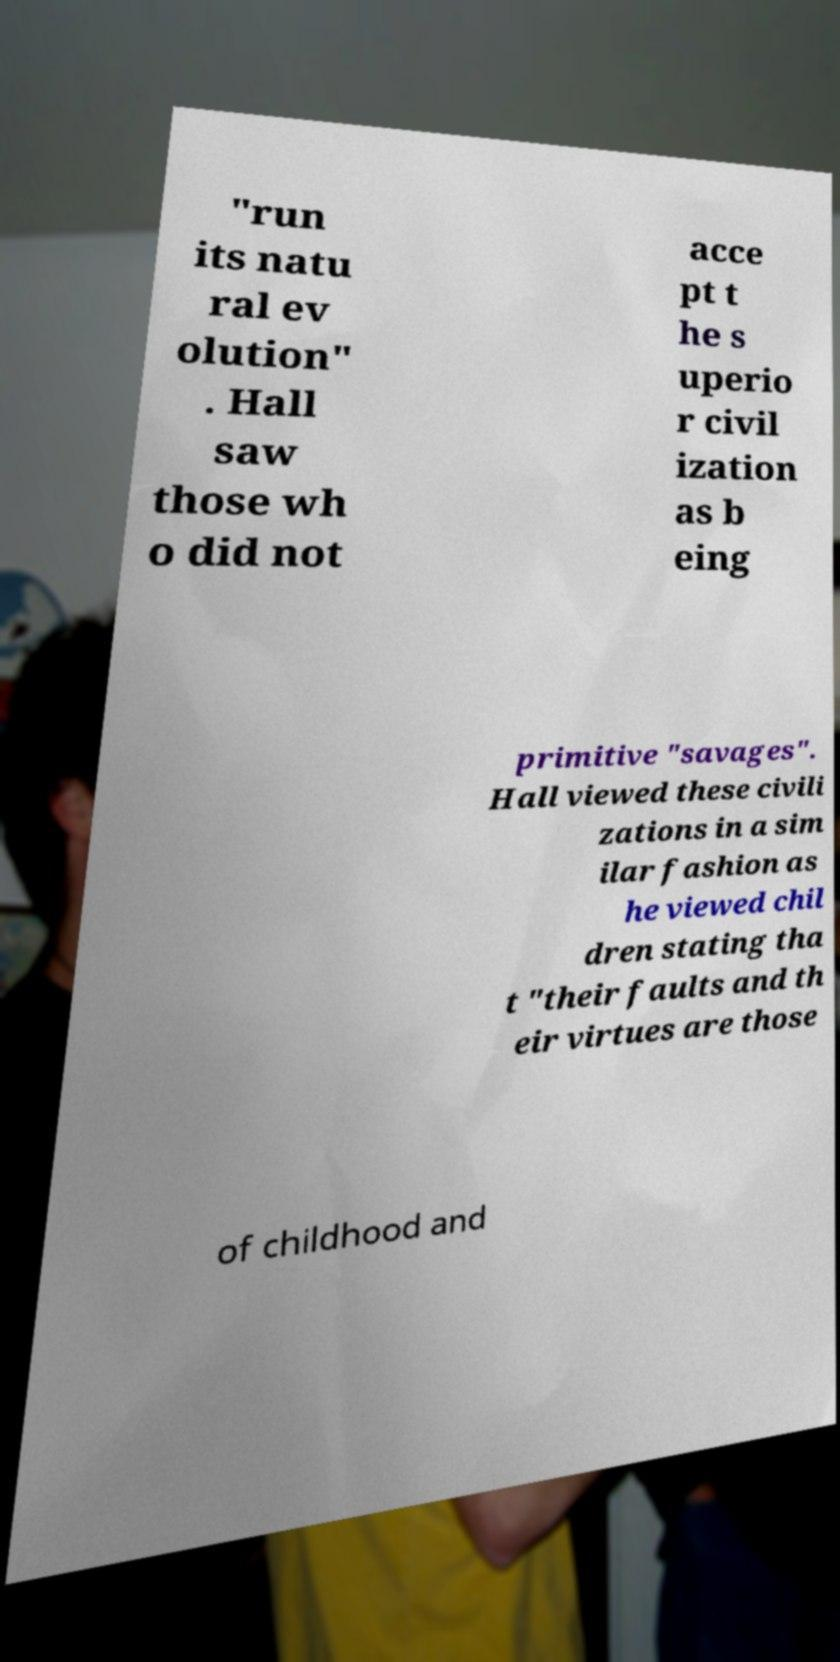Please read and relay the text visible in this image. What does it say? "run its natu ral ev olution" . Hall saw those wh o did not acce pt t he s uperio r civil ization as b eing primitive "savages". Hall viewed these civili zations in a sim ilar fashion as he viewed chil dren stating tha t "their faults and th eir virtues are those of childhood and 